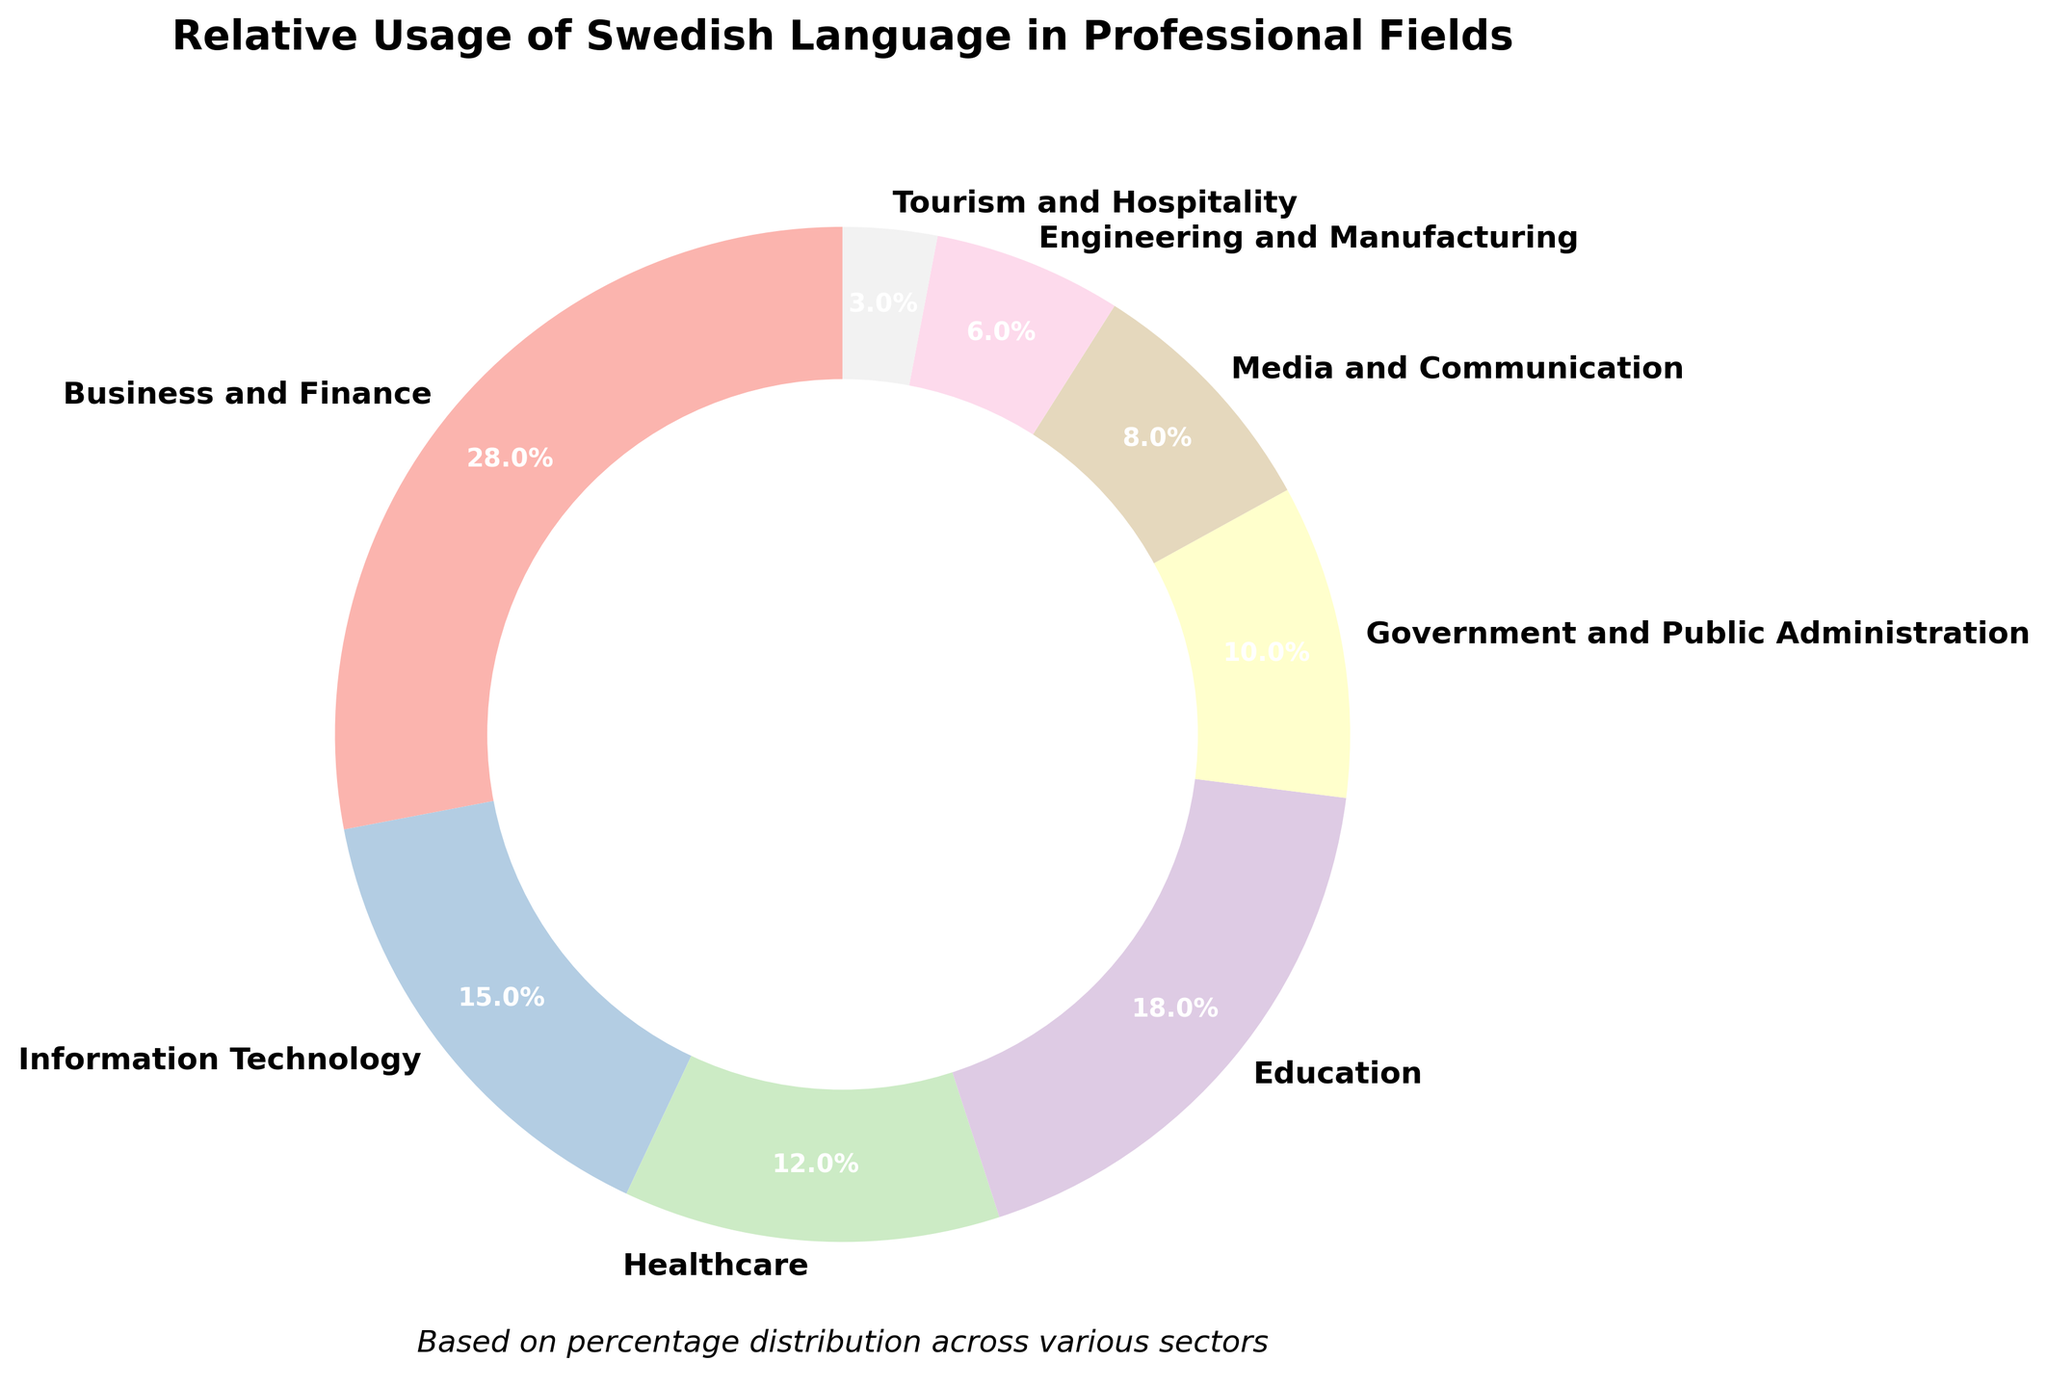What's the largest professional field using Swedish? The largest slice in the pie chart represents "Business and Finance," which has the highest percentage at 28%.
Answer: Business and Finance Which professional field has the smallest usage of Swedish? The smallest slice in the pie chart belongs to "Tourism and Hospitality," with a percentage of 3%.
Answer: Tourism and Hospitality How do Information Technology and Healthcare compare in their usage of Swedish? Information Technology (15%) has a higher usage of Swedish than Healthcare (12%) as indicated by the chart.
Answer: Information Technology What's the combined percentage for the Government and Public Administration and Media and Communication fields? Government and Public Administration is 10% and Media and Communication is 8%. Adding these percentages, 10% + 8% = 18%.
Answer: 18% What is the difference in the percentage usage of Swedish between Engineering and Manufacturing and Education? Education has a percentage of 18%, whereas Engineering and Manufacturing have 6%. The difference is 18% - 6% = 12%.
Answer: 12% Which field's percentage use of Swedish is closest to 20%? The percentage closest to 20% is that of Education, which is 18%.
Answer: Education Which field has a color that corresponds to the first segment in a custom pastel color palette? The business and finance field, whose wedge is closest to the starting angle (90 degrees), uses the first color in the pastel palette.
Answer: Business and Finance Name two fields that together account for around one-third of the total usage of Swedish in professional fields. Information Technology (15%) and Education (18%) together sum to 33%, which is approximately one-third of the total.
Answer: Information Technology and Education What's the combined percentage for Information Technology, Healthcare, and Engineering and Manufacturing? Information Technology is 15%, Healthcare is 12%, and Engineering and Manufacturing is 6%. Adding these percentages together gives 15% + 12% + 6% = 33%.
Answer: 33% How does the usage of Swedish in Media and Communication compare to Tourism and Hospitality? Media and Communication usage of Swedish is 8%, which is greater than Tourism and Hospitality's 3%.
Answer: Media and Communication 